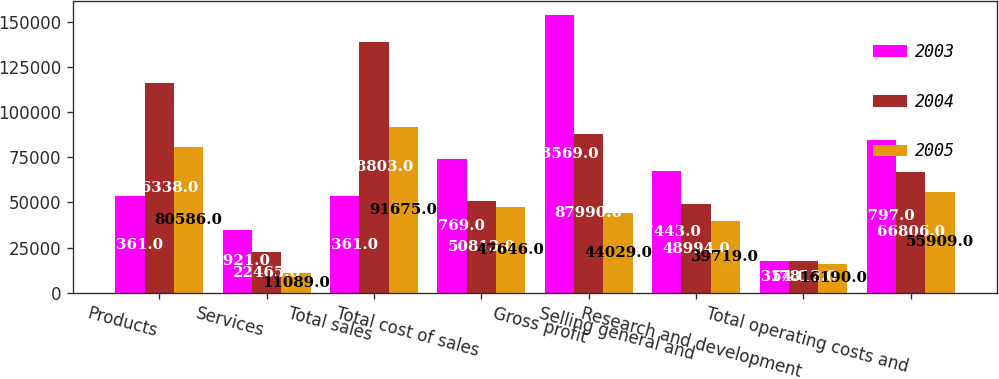<chart> <loc_0><loc_0><loc_500><loc_500><stacked_bar_chart><ecel><fcel>Products<fcel>Services<fcel>Total sales<fcel>Total cost of sales<fcel>Gross profit<fcel>Selling general and<fcel>Research and development<fcel>Total operating costs and<nl><fcel>2003<fcel>53361<fcel>34921<fcel>53361<fcel>73769<fcel>153569<fcel>67443<fcel>17354<fcel>84797<nl><fcel>2004<fcel>116338<fcel>22465<fcel>138803<fcel>50813<fcel>87990<fcel>48994<fcel>17812<fcel>66806<nl><fcel>2005<fcel>80586<fcel>11089<fcel>91675<fcel>47646<fcel>44029<fcel>39719<fcel>16190<fcel>55909<nl></chart> 